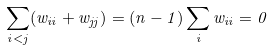<formula> <loc_0><loc_0><loc_500><loc_500>\sum _ { i < j } ( w _ { i i } + w _ { j j } ) = ( n - 1 ) \sum _ { i } w _ { i i } = 0</formula> 